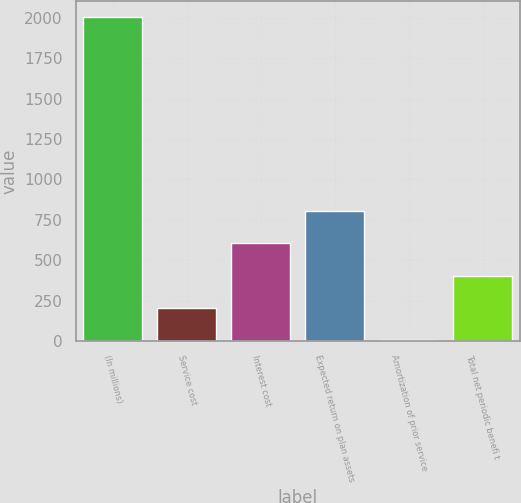Convert chart. <chart><loc_0><loc_0><loc_500><loc_500><bar_chart><fcel>(In millions)<fcel>Service cost<fcel>Interest cost<fcel>Expected return on plan assets<fcel>Amortization of prior service<fcel>Total net periodic benefi t<nl><fcel>2005<fcel>204.73<fcel>604.79<fcel>804.82<fcel>4.7<fcel>404.76<nl></chart> 